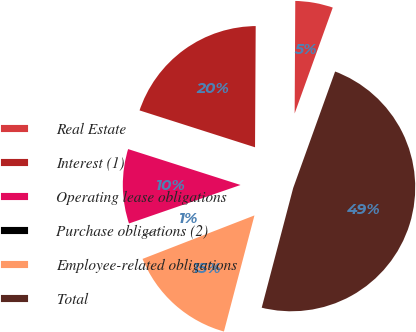<chart> <loc_0><loc_0><loc_500><loc_500><pie_chart><fcel>Real Estate<fcel>Interest (1)<fcel>Operating lease obligations<fcel>Purchase obligations (2)<fcel>Employee-related obligations<fcel>Total<nl><fcel>5.41%<fcel>20.17%<fcel>10.21%<fcel>0.61%<fcel>15.01%<fcel>48.6%<nl></chart> 